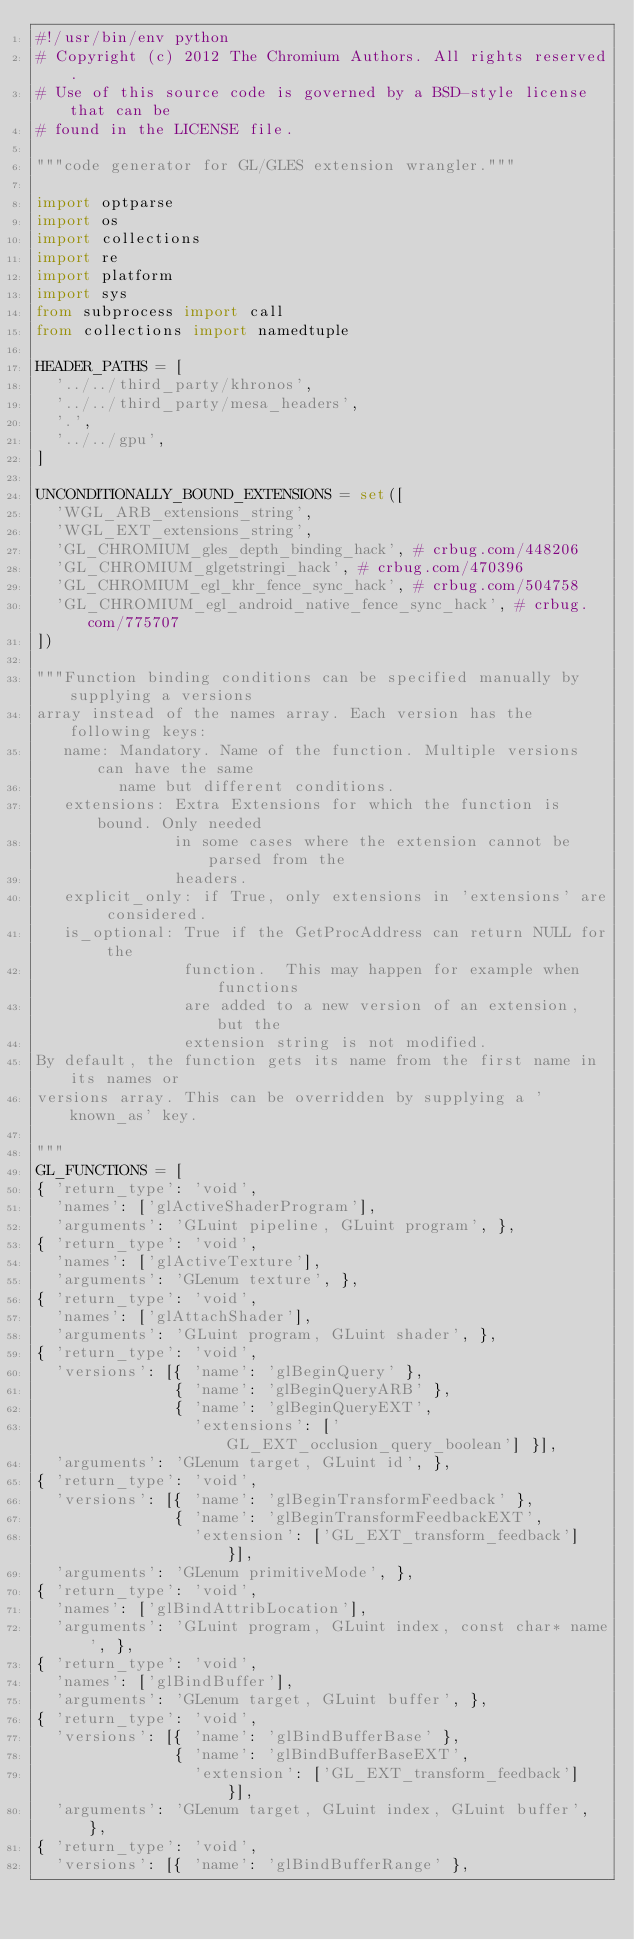Convert code to text. <code><loc_0><loc_0><loc_500><loc_500><_Python_>#!/usr/bin/env python
# Copyright (c) 2012 The Chromium Authors. All rights reserved.
# Use of this source code is governed by a BSD-style license that can be
# found in the LICENSE file.

"""code generator for GL/GLES extension wrangler."""

import optparse
import os
import collections
import re
import platform
import sys
from subprocess import call
from collections import namedtuple

HEADER_PATHS = [
  '../../third_party/khronos',
  '../../third_party/mesa_headers',
  '.',
  '../../gpu',
]

UNCONDITIONALLY_BOUND_EXTENSIONS = set([
  'WGL_ARB_extensions_string',
  'WGL_EXT_extensions_string',
  'GL_CHROMIUM_gles_depth_binding_hack', # crbug.com/448206
  'GL_CHROMIUM_glgetstringi_hack', # crbug.com/470396
  'GL_CHROMIUM_egl_khr_fence_sync_hack', # crbug.com/504758
  'GL_CHROMIUM_egl_android_native_fence_sync_hack', # crbug.com/775707
])

"""Function binding conditions can be specified manually by supplying a versions
array instead of the names array. Each version has the following keys:
   name: Mandatory. Name of the function. Multiple versions can have the same
         name but different conditions.
   extensions: Extra Extensions for which the function is bound. Only needed
               in some cases where the extension cannot be parsed from the
               headers.
   explicit_only: if True, only extensions in 'extensions' are considered.
   is_optional: True if the GetProcAddress can return NULL for the
                function.  This may happen for example when functions
                are added to a new version of an extension, but the
                extension string is not modified.
By default, the function gets its name from the first name in its names or
versions array. This can be overridden by supplying a 'known_as' key.

"""
GL_FUNCTIONS = [
{ 'return_type': 'void',
  'names': ['glActiveShaderProgram'],
  'arguments': 'GLuint pipeline, GLuint program', },
{ 'return_type': 'void',
  'names': ['glActiveTexture'],
  'arguments': 'GLenum texture', },
{ 'return_type': 'void',
  'names': ['glAttachShader'],
  'arguments': 'GLuint program, GLuint shader', },
{ 'return_type': 'void',
  'versions': [{ 'name': 'glBeginQuery' },
               { 'name': 'glBeginQueryARB' },
               { 'name': 'glBeginQueryEXT',
                 'extensions': ['GL_EXT_occlusion_query_boolean'] }],
  'arguments': 'GLenum target, GLuint id', },
{ 'return_type': 'void',
  'versions': [{ 'name': 'glBeginTransformFeedback' },
               { 'name': 'glBeginTransformFeedbackEXT',
                 'extension': ['GL_EXT_transform_feedback'] }],
  'arguments': 'GLenum primitiveMode', },
{ 'return_type': 'void',
  'names': ['glBindAttribLocation'],
  'arguments': 'GLuint program, GLuint index, const char* name', },
{ 'return_type': 'void',
  'names': ['glBindBuffer'],
  'arguments': 'GLenum target, GLuint buffer', },
{ 'return_type': 'void',
  'versions': [{ 'name': 'glBindBufferBase' },
               { 'name': 'glBindBufferBaseEXT',
                 'extension': ['GL_EXT_transform_feedback'] }],
  'arguments': 'GLenum target, GLuint index, GLuint buffer', },
{ 'return_type': 'void',
  'versions': [{ 'name': 'glBindBufferRange' },</code> 